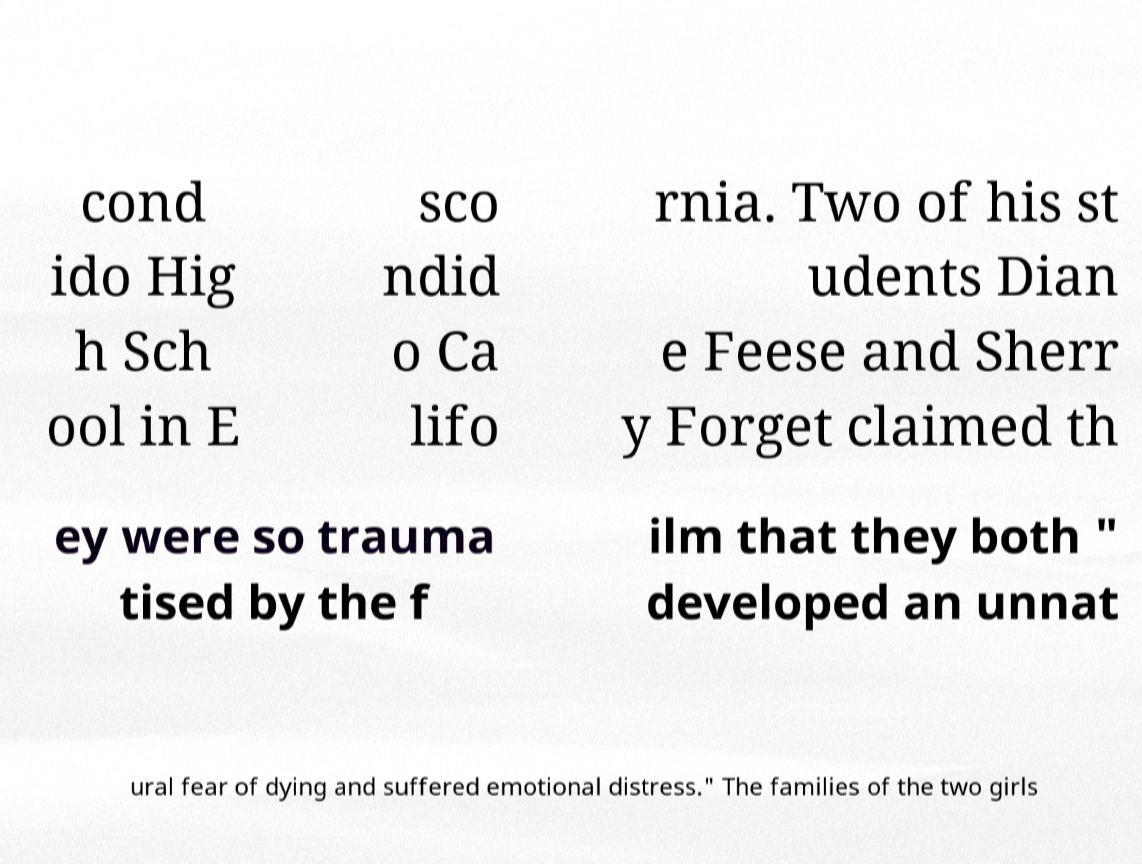Please read and relay the text visible in this image. What does it say? cond ido Hig h Sch ool in E sco ndid o Ca lifo rnia. Two of his st udents Dian e Feese and Sherr y Forget claimed th ey were so trauma tised by the f ilm that they both " developed an unnat ural fear of dying and suffered emotional distress." The families of the two girls 